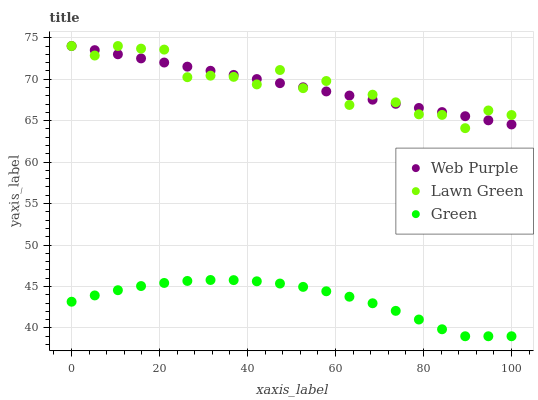Does Green have the minimum area under the curve?
Answer yes or no. Yes. Does Lawn Green have the maximum area under the curve?
Answer yes or no. Yes. Does Web Purple have the minimum area under the curve?
Answer yes or no. No. Does Web Purple have the maximum area under the curve?
Answer yes or no. No. Is Web Purple the smoothest?
Answer yes or no. Yes. Is Lawn Green the roughest?
Answer yes or no. Yes. Is Green the smoothest?
Answer yes or no. No. Is Green the roughest?
Answer yes or no. No. Does Green have the lowest value?
Answer yes or no. Yes. Does Web Purple have the lowest value?
Answer yes or no. No. Does Web Purple have the highest value?
Answer yes or no. Yes. Does Green have the highest value?
Answer yes or no. No. Is Green less than Lawn Green?
Answer yes or no. Yes. Is Web Purple greater than Green?
Answer yes or no. Yes. Does Lawn Green intersect Web Purple?
Answer yes or no. Yes. Is Lawn Green less than Web Purple?
Answer yes or no. No. Is Lawn Green greater than Web Purple?
Answer yes or no. No. Does Green intersect Lawn Green?
Answer yes or no. No. 